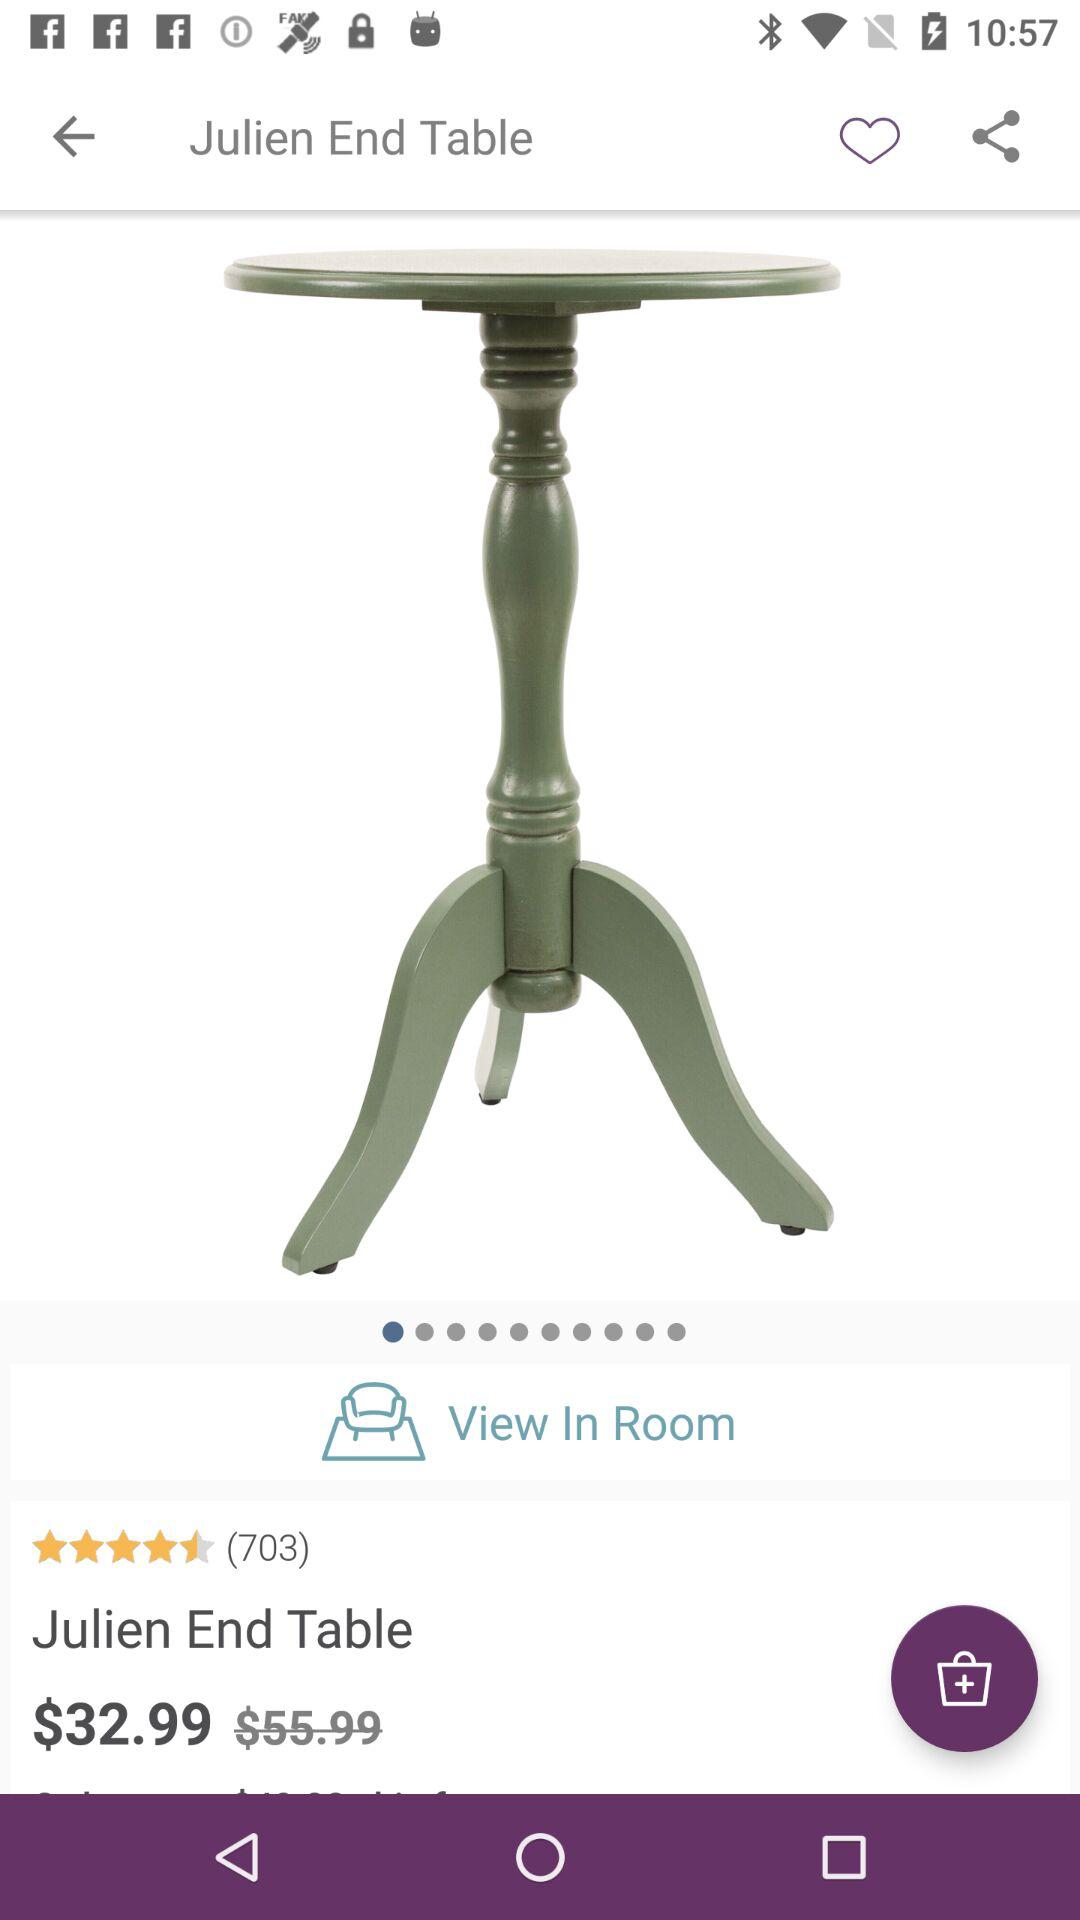What is the price of a table? The price of a table is $32.99. 